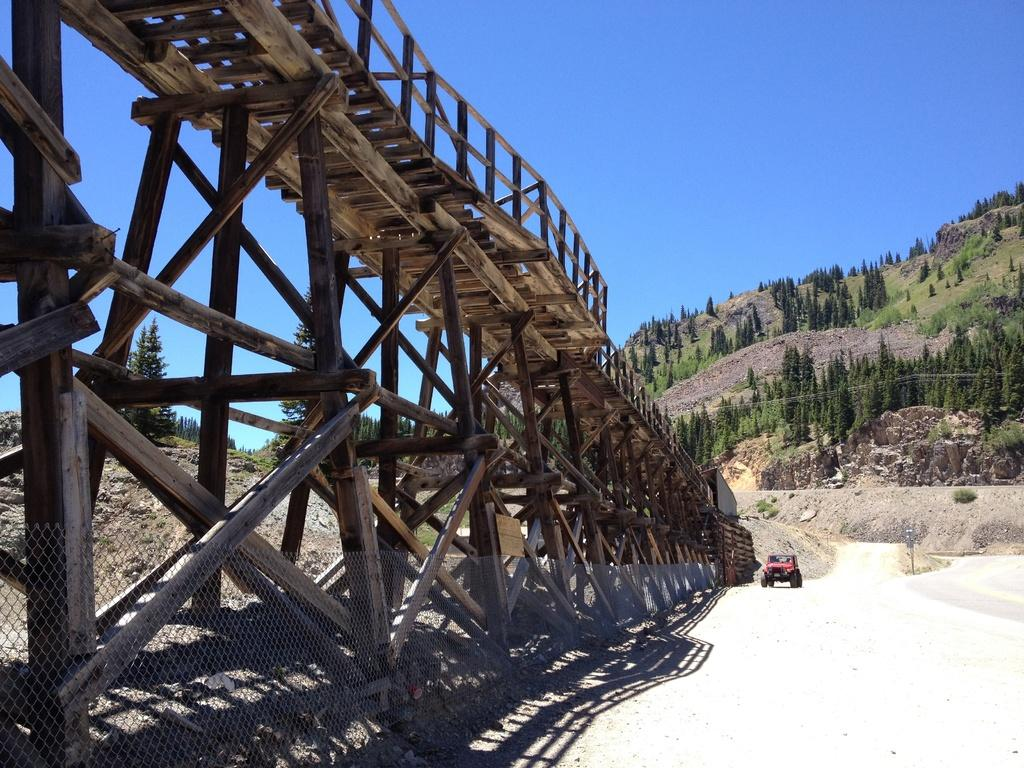What type of structure can be seen in the image? There is a fence and a bridge in the image. What is located near the fence? There is a vehicle beside the fence. What can be seen in the background of the image? There are trees and rocks in the background of the image. What type of oatmeal is being sorted by the bucket in the image? There is no bucket or oatmeal present in the image. 